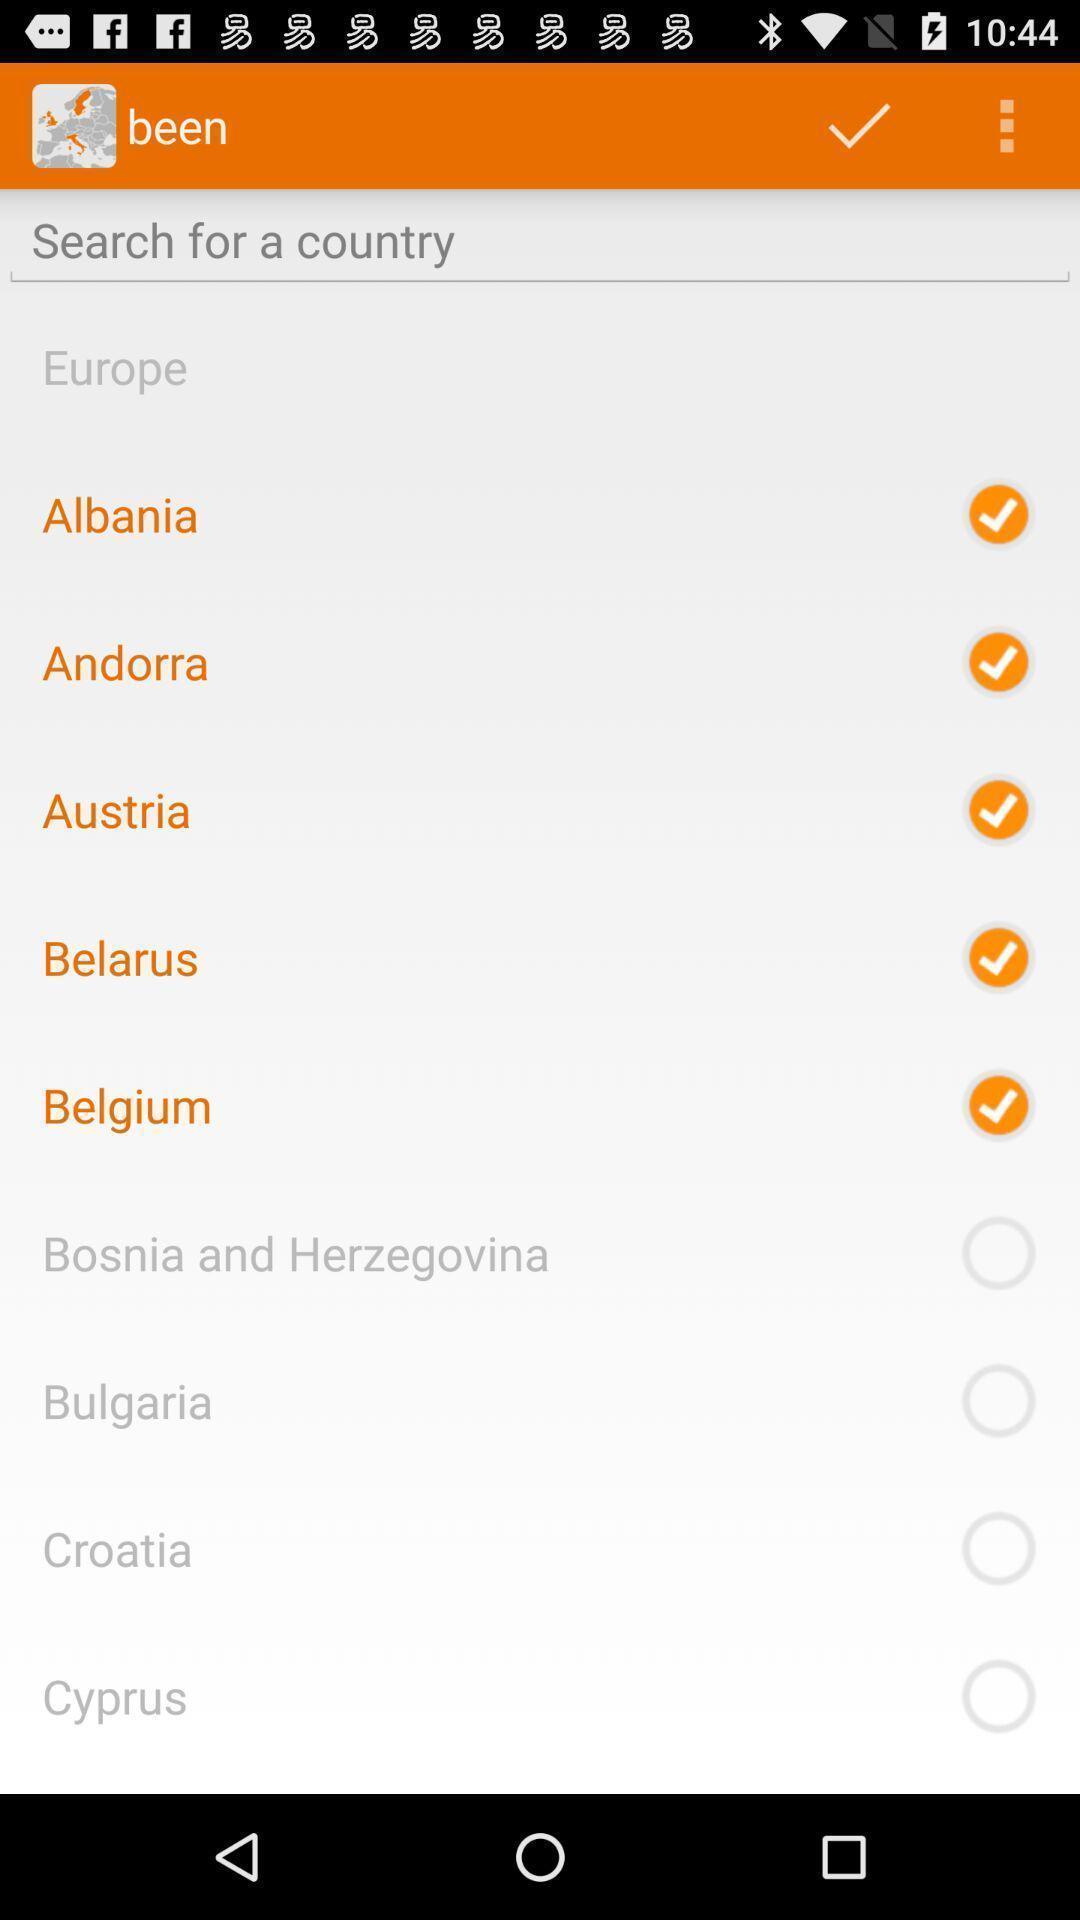Give me a summary of this screen capture. Screen showing list of various countries for an app. 